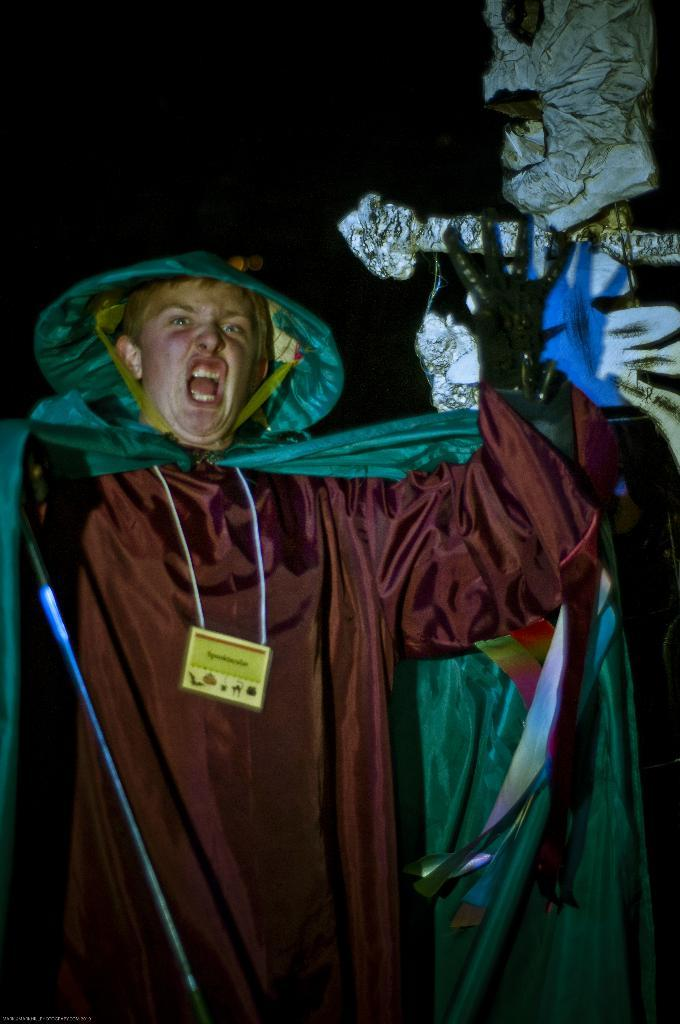What is the person in the image wearing? The person is wearing a costume in the image. How can the person be identified in the image? The person is wearing a tag in the image. What can be seen on the right side of the image? There is a statue on the right side of the image. What is the color of the background in the image? The background of the image is dark. What type of pie is being served on the dirt in the image? There is no pie or dirt present in the image. 